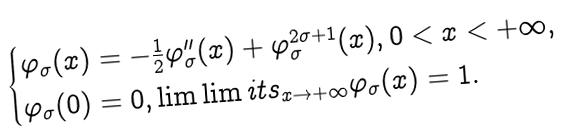<formula> <loc_0><loc_0><loc_500><loc_500>\begin{cases} \varphi _ { \sigma } ( x ) = - \frac { 1 } { 2 } \varphi _ { \sigma } ^ { \prime \prime } ( x ) + \varphi _ { \sigma } ^ { 2 \sigma + 1 } ( x ) , 0 < x < + \infty , \\ \varphi _ { \sigma } ( 0 ) = 0 , \lim \lim i t s _ { x \to + \infty } \varphi _ { \sigma } ( x ) = 1 . \end{cases}</formula> 